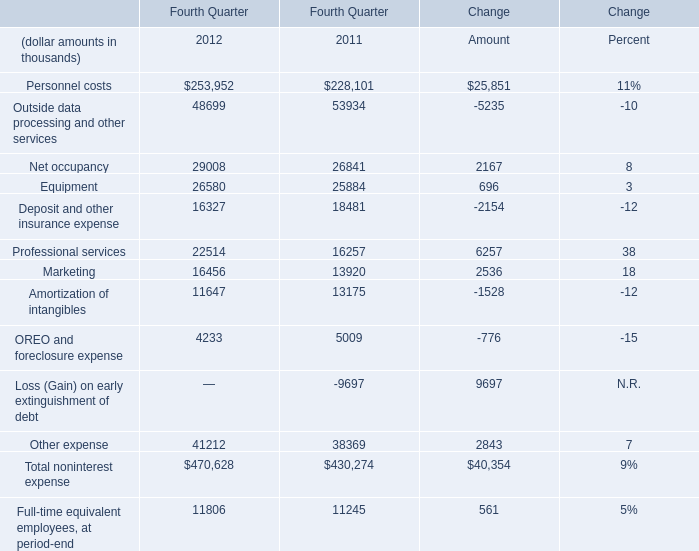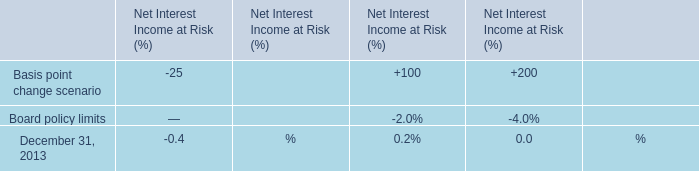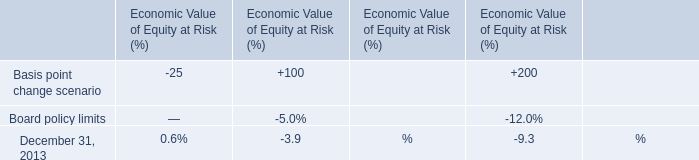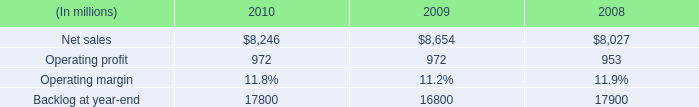In the year with the most equipment, what is the growth rate of marketing? (in %) 
Computations: ((16456 - 13920) / 13920)
Answer: 0.18218. 